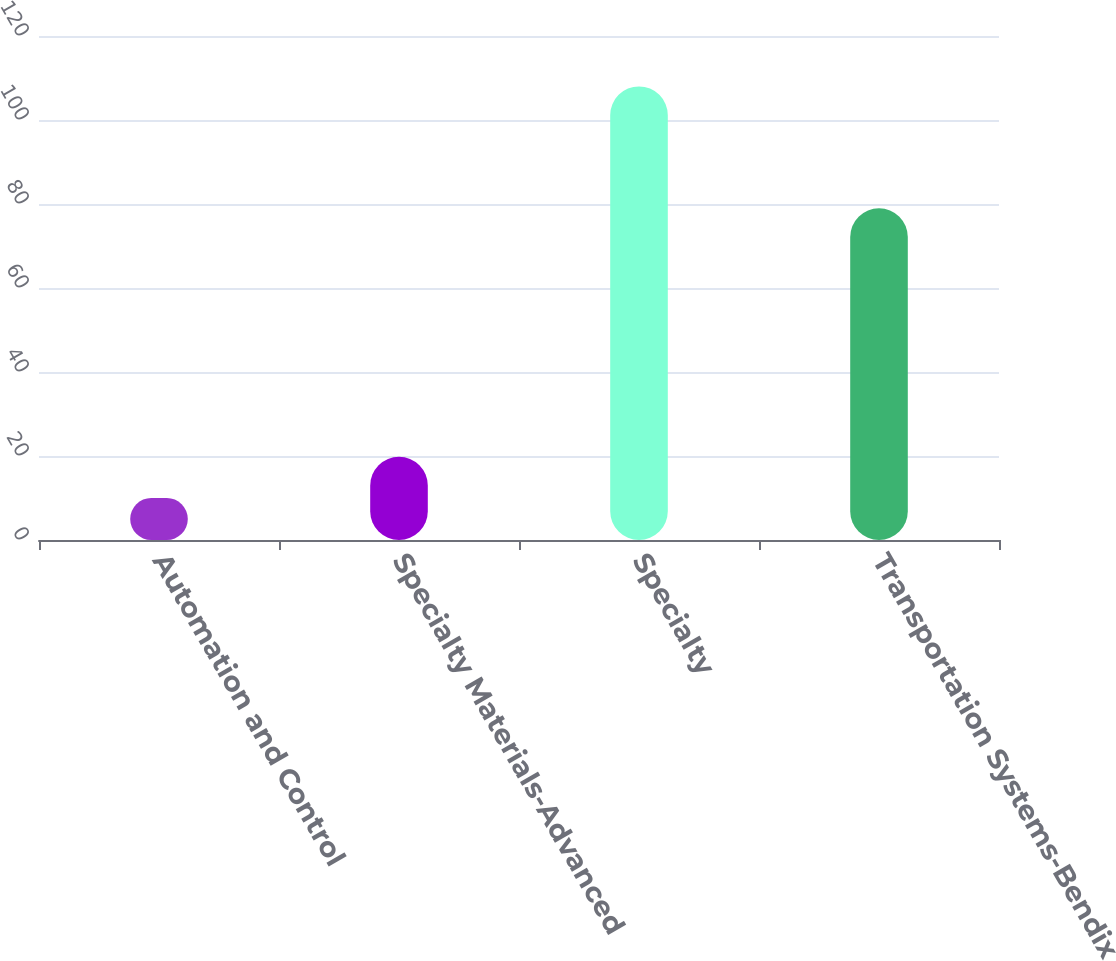Convert chart. <chart><loc_0><loc_0><loc_500><loc_500><bar_chart><fcel>Automation and Control<fcel>Specialty Materials-Advanced<fcel>Specialty<fcel>Transportation Systems-Bendix<nl><fcel>10<fcel>19.8<fcel>108<fcel>79<nl></chart> 